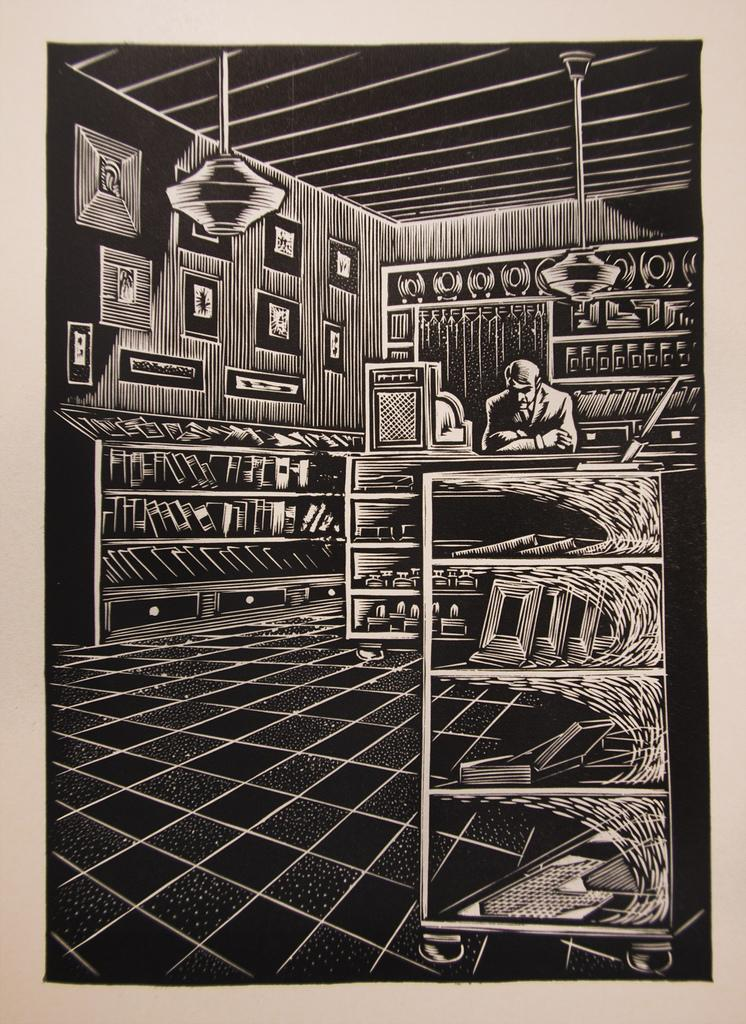<image>
Provide a brief description of the given image. a black and white picture of a store with absolutely no words to read at all 